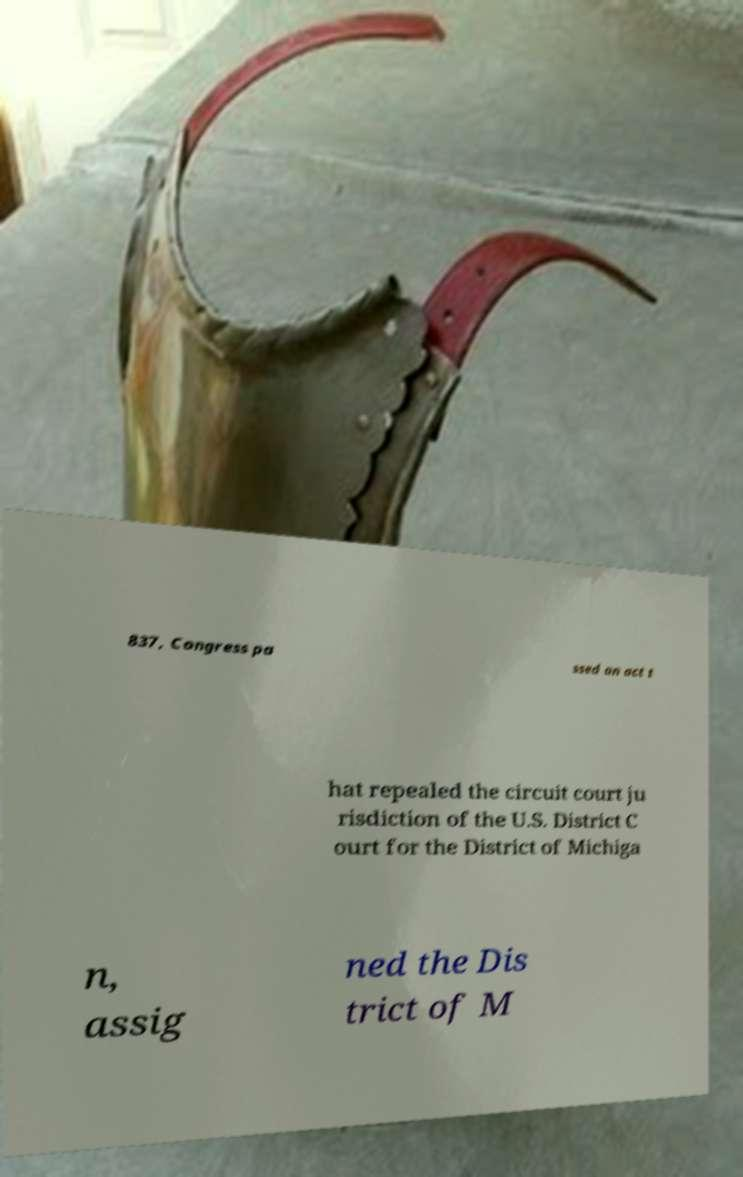I need the written content from this picture converted into text. Can you do that? 837, Congress pa ssed an act t hat repealed the circuit court ju risdiction of the U.S. District C ourt for the District of Michiga n, assig ned the Dis trict of M 